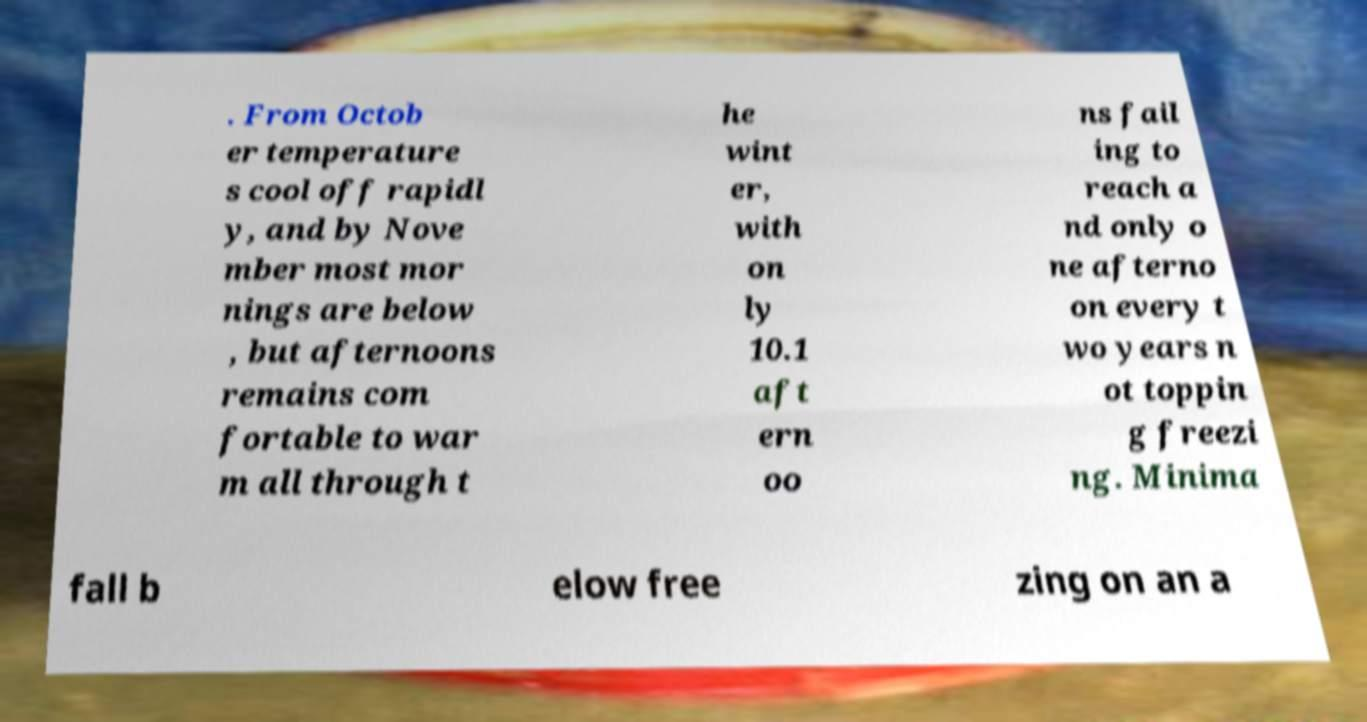For documentation purposes, I need the text within this image transcribed. Could you provide that? . From Octob er temperature s cool off rapidl y, and by Nove mber most mor nings are below , but afternoons remains com fortable to war m all through t he wint er, with on ly 10.1 aft ern oo ns fail ing to reach a nd only o ne afterno on every t wo years n ot toppin g freezi ng. Minima fall b elow free zing on an a 